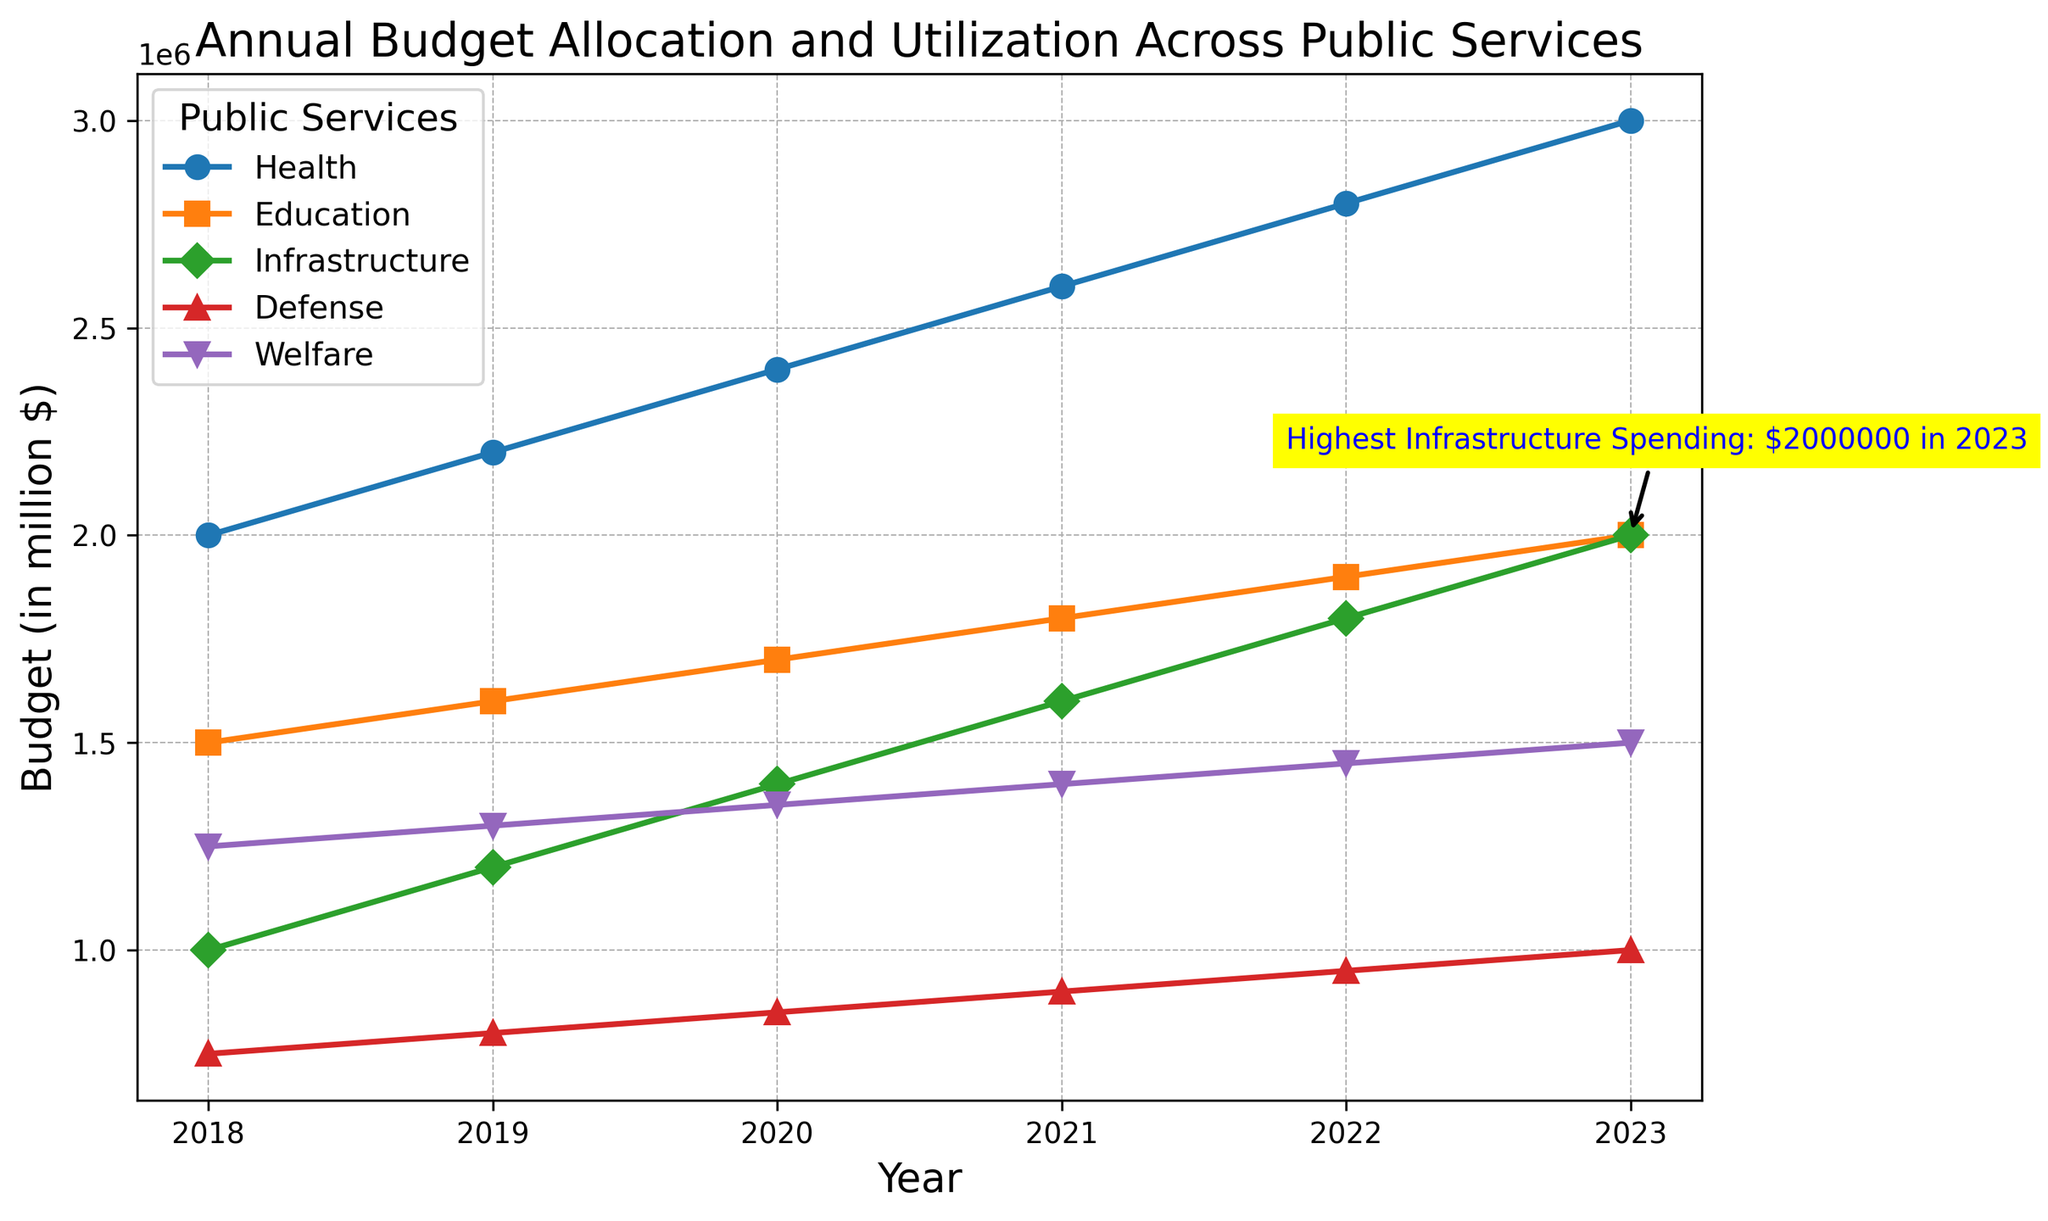What year had the highest infrastructure spending? The figure highlights the year with the highest infrastructure spending with an annotation, pointing to 2023.
Answer: 2023 Which public service had the highest budget in 2022? By observing the height of the lines in the figure for the year 2022, it can be seen that the "Health" budget is the highest among all services.
Answer: Health What was the total budget allocated for Defense and Welfare in 2021? Adding the values for Defense ($900,000) and Welfare ($1,400,000) shown in the figure for 2021: $900,000 + $1,400,000 = $2,300,000.
Answer: $2,300,000 How much did the education budget increase from 2018 to 2023? Subtracting the education budget in 2018 ($1,500,000) from that in 2023 ($2,000,000): $2,000,000 - $1,500,000 = $500,000.
Answer: $500,000 Which service had the least increase in budget from 2018 to 2023? By comparing the budget increases for all services during this period: Health ($1,000,000), Education ($500,000), Infrastructure ($1,000,000), Defense ($250,000), and Welfare ($250,000), the least increase was in Defense and Welfare with $250,000 each.
Answer: Defense and Welfare How did welfare spending change over the years 2018-2023? Observing the trend for Welfare in the figure, the budget increases gradually each year from $1,250,000 in 2018 to $1,500,000 in 2023.
Answer: Gradual increase Which service displayed the steepest increase between any two consecutive years and when did it occur? By examining the slopes, the steepest increase is seen for Infrastructure from 2019 ($1,200,000) to 2020 ($1,400,000) with an increase of $200,000.
Answer: Infrastructure (2019 to 2020) What is the average annual budget for Health from 2018 to 2023? Calculating the average of Health budgets over six years: (2,000,000 + 2,200,000 + 2,400,000 + 2,600,000 + 2,800,000 + 3,000,000) / 6 = $2,500,000.
Answer: $2,500,000 How did the defense budget compare to the welfare budget in 2020? Observing the figure, in 2020 the Defense budget was $850,000 and the Welfare budget was $1,350,000, so the Defense budget was less than the Welfare budget.
Answer: Less than 